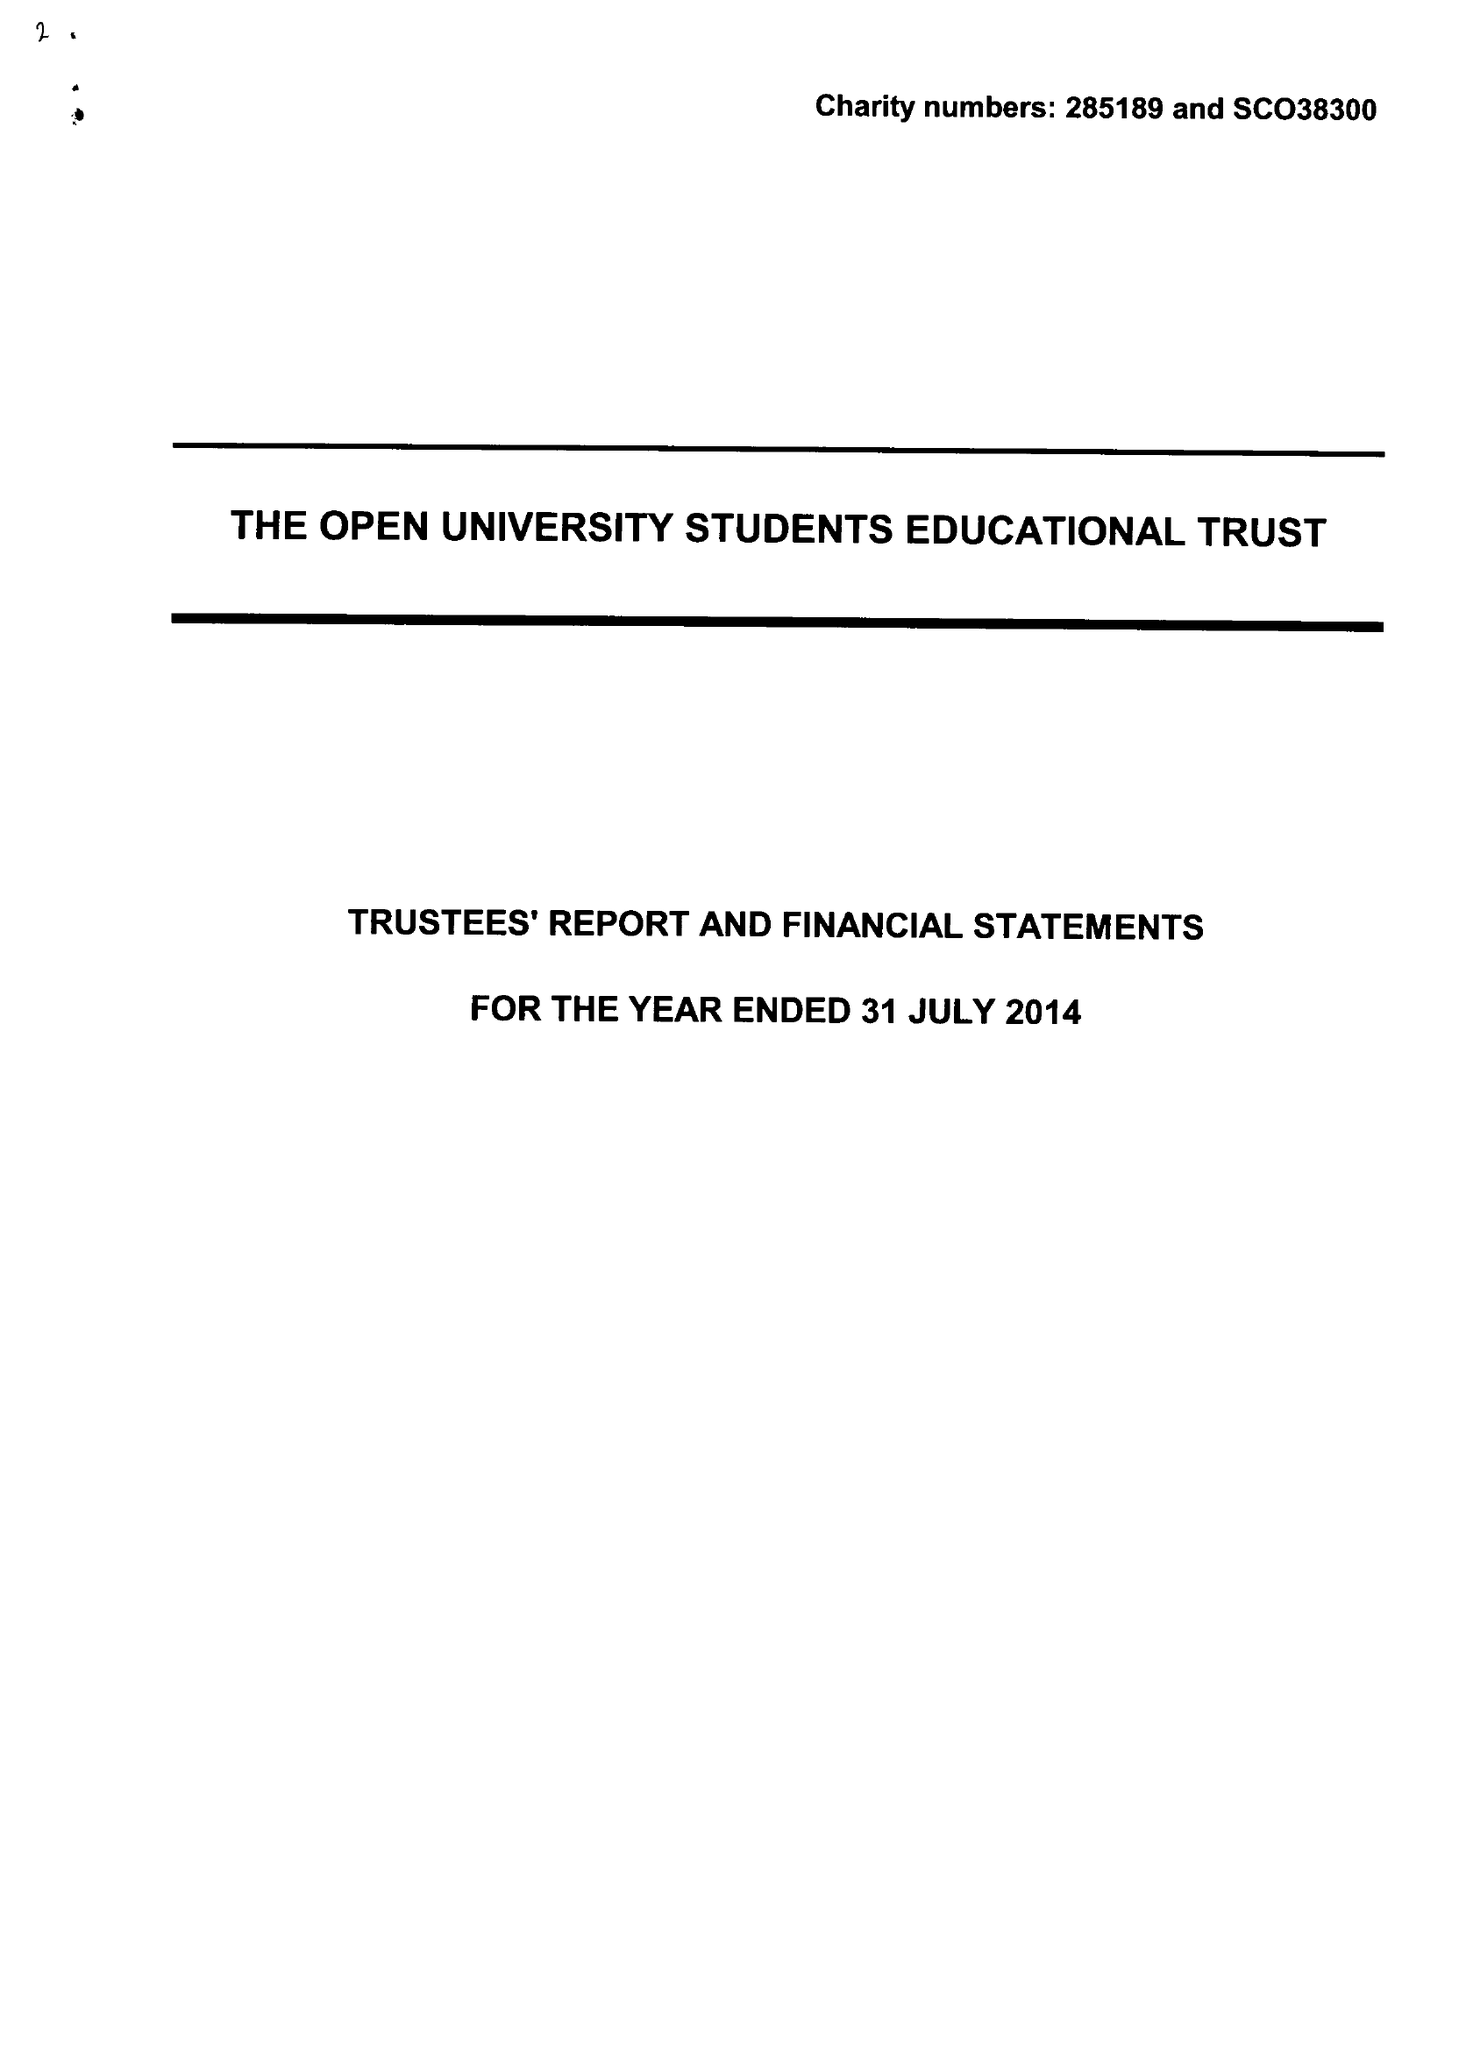What is the value for the address__post_town?
Answer the question using a single word or phrase. MILTON KEYNES 